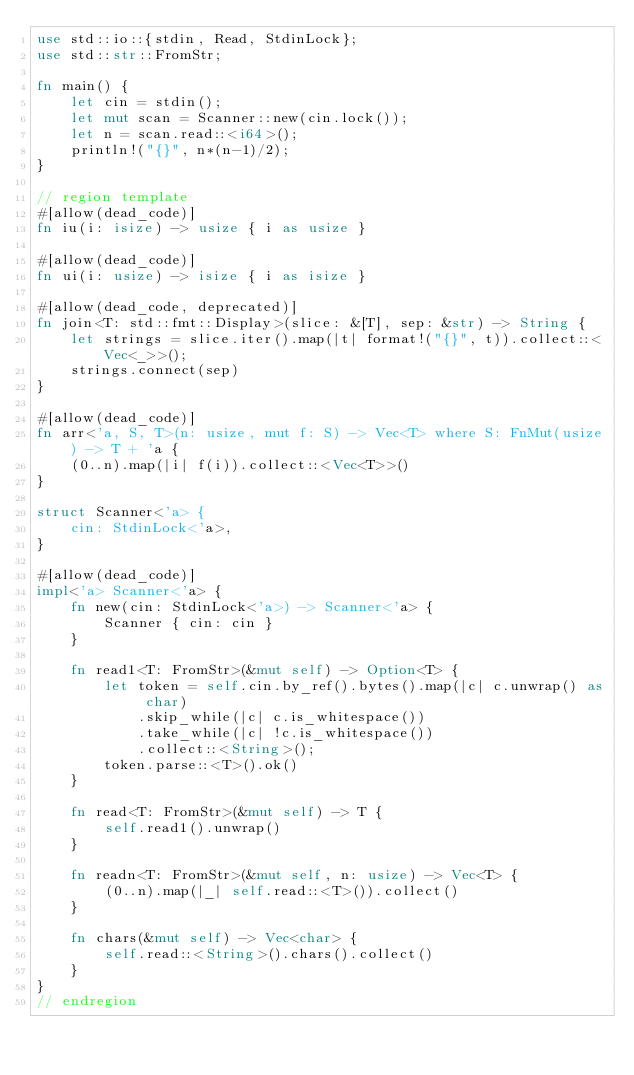Convert code to text. <code><loc_0><loc_0><loc_500><loc_500><_Rust_>use std::io::{stdin, Read, StdinLock};
use std::str::FromStr;

fn main() {
    let cin = stdin();
    let mut scan = Scanner::new(cin.lock());
    let n = scan.read::<i64>();
    println!("{}", n*(n-1)/2);
}

// region template
#[allow(dead_code)]
fn iu(i: isize) -> usize { i as usize }

#[allow(dead_code)]
fn ui(i: usize) -> isize { i as isize }

#[allow(dead_code, deprecated)]
fn join<T: std::fmt::Display>(slice: &[T], sep: &str) -> String {
    let strings = slice.iter().map(|t| format!("{}", t)).collect::<Vec<_>>();
    strings.connect(sep)
}

#[allow(dead_code)]
fn arr<'a, S, T>(n: usize, mut f: S) -> Vec<T> where S: FnMut(usize) -> T + 'a {
    (0..n).map(|i| f(i)).collect::<Vec<T>>()
}

struct Scanner<'a> {
    cin: StdinLock<'a>,
}

#[allow(dead_code)]
impl<'a> Scanner<'a> {
    fn new(cin: StdinLock<'a>) -> Scanner<'a> {
        Scanner { cin: cin }
    }

    fn read1<T: FromStr>(&mut self) -> Option<T> {
        let token = self.cin.by_ref().bytes().map(|c| c.unwrap() as char)
            .skip_while(|c| c.is_whitespace())
            .take_while(|c| !c.is_whitespace())
            .collect::<String>();
        token.parse::<T>().ok()
    }

    fn read<T: FromStr>(&mut self) -> T {
        self.read1().unwrap()
    }

    fn readn<T: FromStr>(&mut self, n: usize) -> Vec<T> {
        (0..n).map(|_| self.read::<T>()).collect()
    }

    fn chars(&mut self) -> Vec<char> {
        self.read::<String>().chars().collect()
    }
}
// endregion</code> 